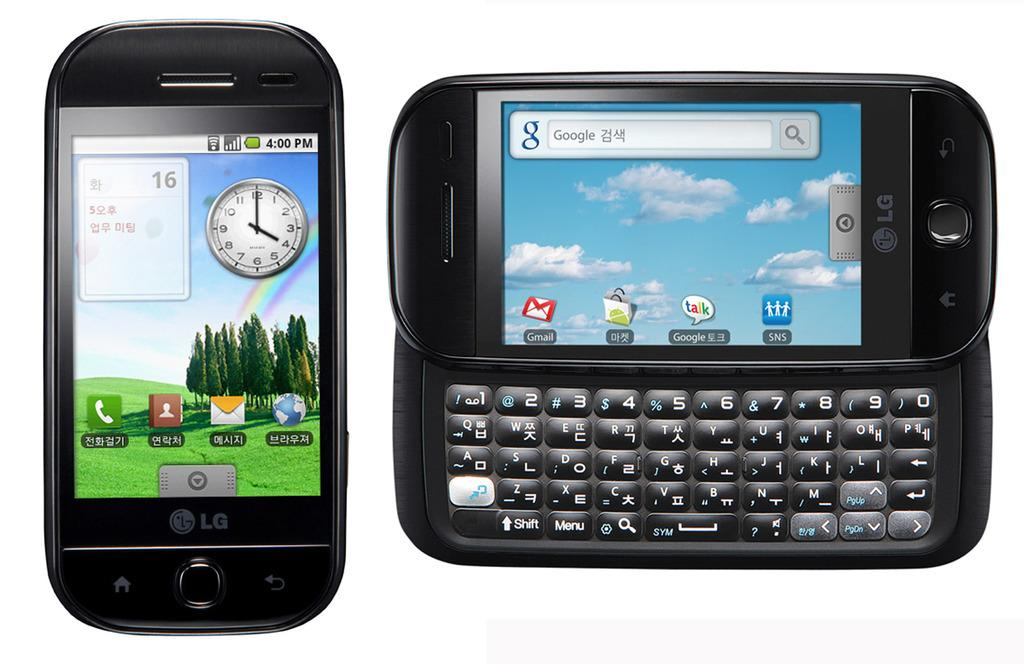<image>
Write a terse but informative summary of the picture. Two devices, one of which is a phone that has the number 16 visible on it 